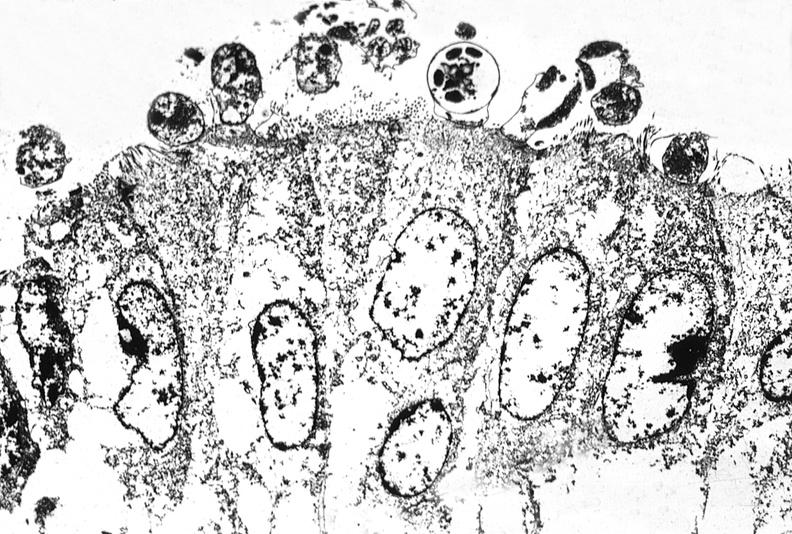s gastrointestinal present?
Answer the question using a single word or phrase. Yes 